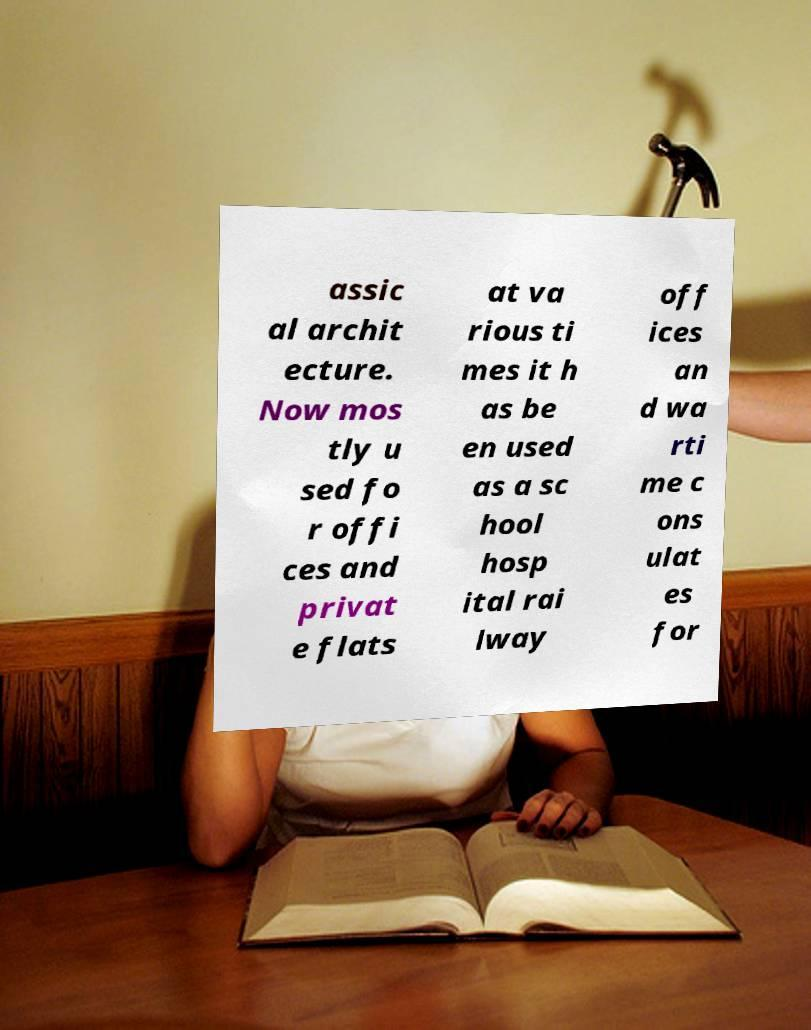Can you read and provide the text displayed in the image?This photo seems to have some interesting text. Can you extract and type it out for me? assic al archit ecture. Now mos tly u sed fo r offi ces and privat e flats at va rious ti mes it h as be en used as a sc hool hosp ital rai lway off ices an d wa rti me c ons ulat es for 